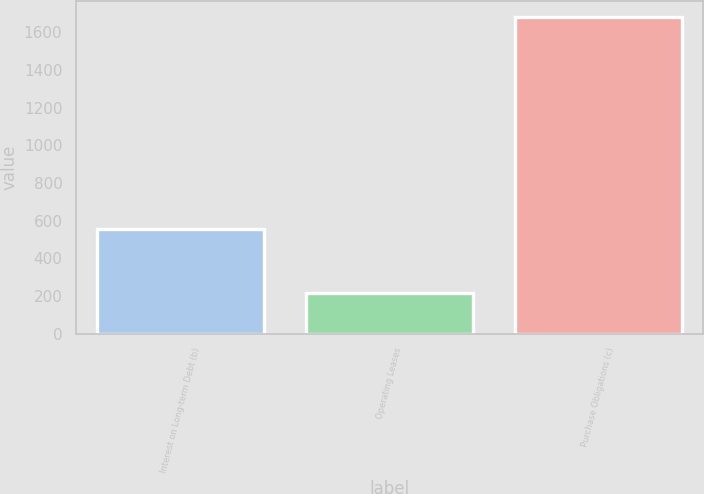Convert chart. <chart><loc_0><loc_0><loc_500><loc_500><bar_chart><fcel>Interest on Long-term Debt (b)<fcel>Operating Leases<fcel>Purchase Obligations (c)<nl><fcel>558<fcel>216<fcel>1680<nl></chart> 